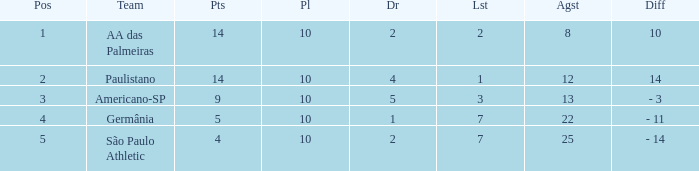What is the highest Drawn when the lost is 7 and the points are more than 4, and the against is less than 22? None. 